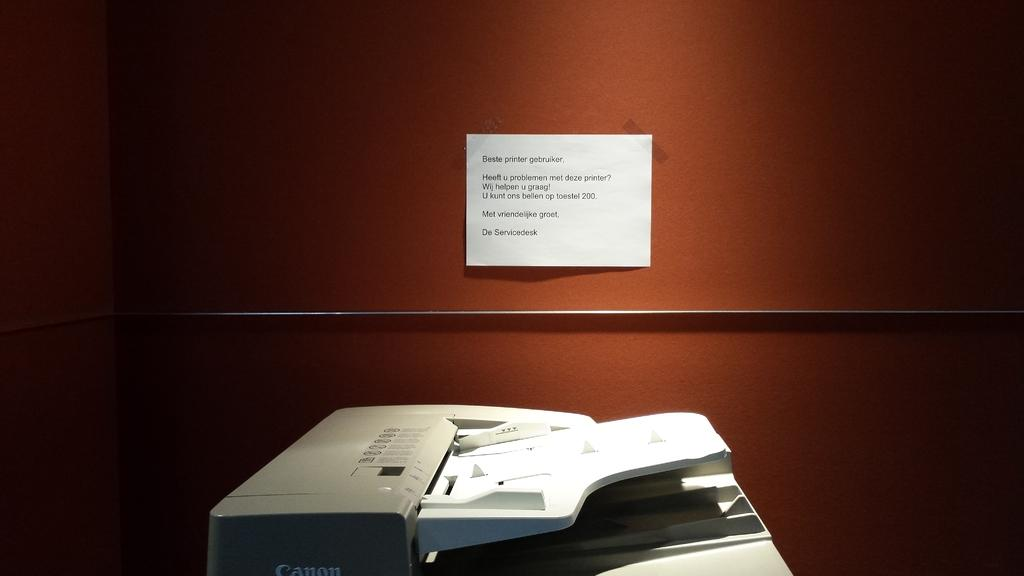What is the main object in the center of the image? There is a xerox machine in the center of the image. What can be seen in the background of the image? There is a wall in the background of the image. Is there any text visible on the wall? Yes, there is a paper with some text on the wall. How many chickens are sitting on the xerox machine in the image? There are no chickens present in the image; the main object is a xerox machine. 